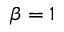Convert formula to latex. <formula><loc_0><loc_0><loc_500><loc_500>\beta = 1</formula> 